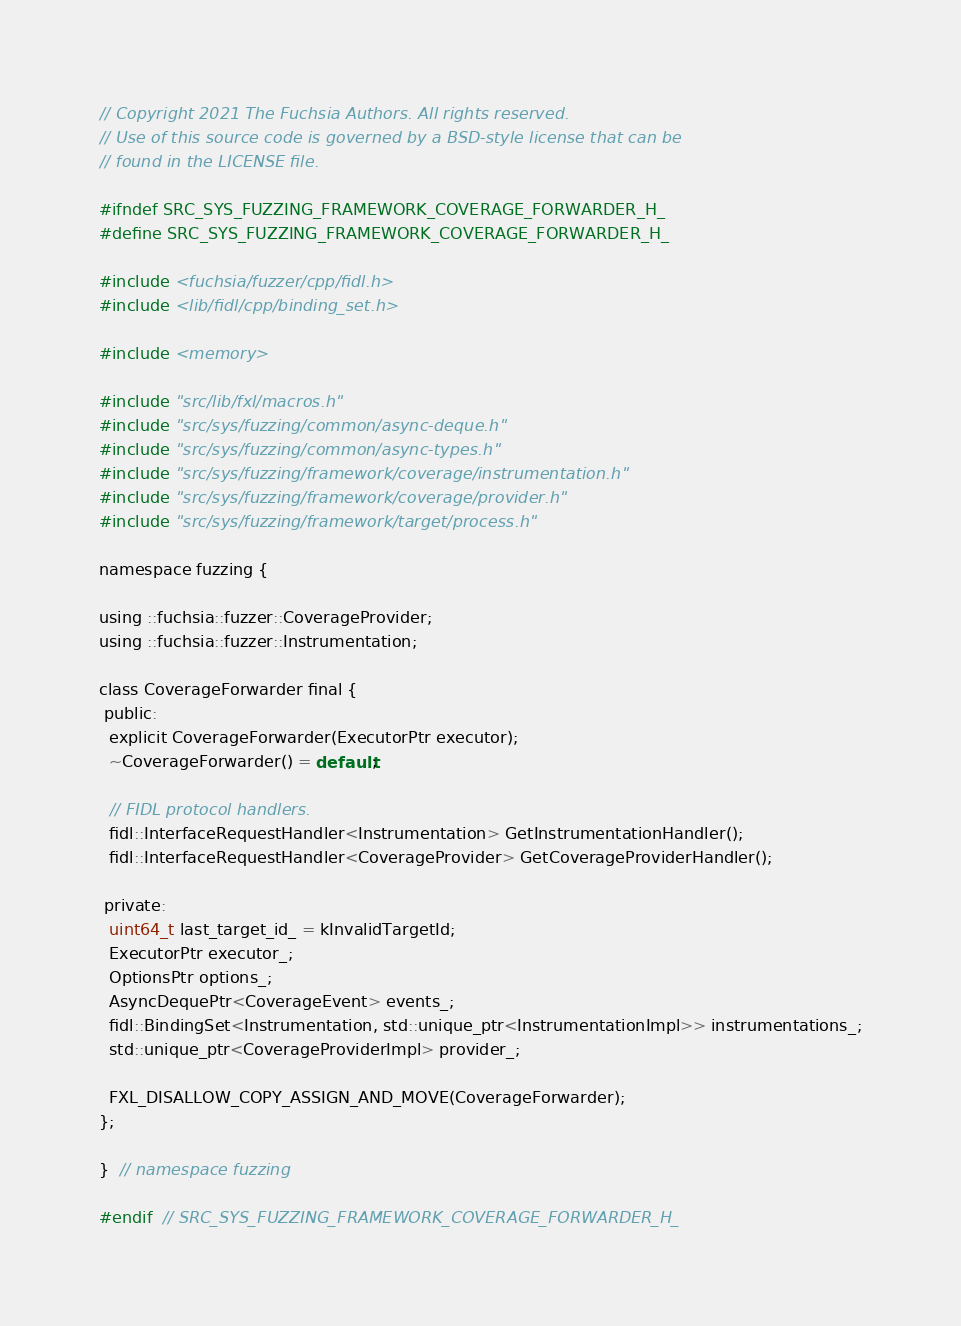<code> <loc_0><loc_0><loc_500><loc_500><_C_>// Copyright 2021 The Fuchsia Authors. All rights reserved.
// Use of this source code is governed by a BSD-style license that can be
// found in the LICENSE file.

#ifndef SRC_SYS_FUZZING_FRAMEWORK_COVERAGE_FORWARDER_H_
#define SRC_SYS_FUZZING_FRAMEWORK_COVERAGE_FORWARDER_H_

#include <fuchsia/fuzzer/cpp/fidl.h>
#include <lib/fidl/cpp/binding_set.h>

#include <memory>

#include "src/lib/fxl/macros.h"
#include "src/sys/fuzzing/common/async-deque.h"
#include "src/sys/fuzzing/common/async-types.h"
#include "src/sys/fuzzing/framework/coverage/instrumentation.h"
#include "src/sys/fuzzing/framework/coverage/provider.h"
#include "src/sys/fuzzing/framework/target/process.h"

namespace fuzzing {

using ::fuchsia::fuzzer::CoverageProvider;
using ::fuchsia::fuzzer::Instrumentation;

class CoverageForwarder final {
 public:
  explicit CoverageForwarder(ExecutorPtr executor);
  ~CoverageForwarder() = default;

  // FIDL protocol handlers.
  fidl::InterfaceRequestHandler<Instrumentation> GetInstrumentationHandler();
  fidl::InterfaceRequestHandler<CoverageProvider> GetCoverageProviderHandler();

 private:
  uint64_t last_target_id_ = kInvalidTargetId;
  ExecutorPtr executor_;
  OptionsPtr options_;
  AsyncDequePtr<CoverageEvent> events_;
  fidl::BindingSet<Instrumentation, std::unique_ptr<InstrumentationImpl>> instrumentations_;
  std::unique_ptr<CoverageProviderImpl> provider_;

  FXL_DISALLOW_COPY_ASSIGN_AND_MOVE(CoverageForwarder);
};

}  // namespace fuzzing

#endif  // SRC_SYS_FUZZING_FRAMEWORK_COVERAGE_FORWARDER_H_
</code> 